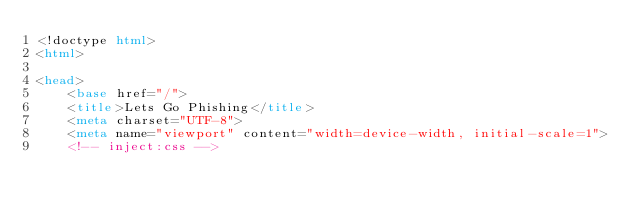Convert code to text. <code><loc_0><loc_0><loc_500><loc_500><_HTML_><!doctype html>
<html>

<head>
    <base href="/">
    <title>Lets Go Phishing</title>
    <meta charset="UTF-8">
    <meta name="viewport" content="width=device-width, initial-scale=1">
    <!-- inject:css --></code> 